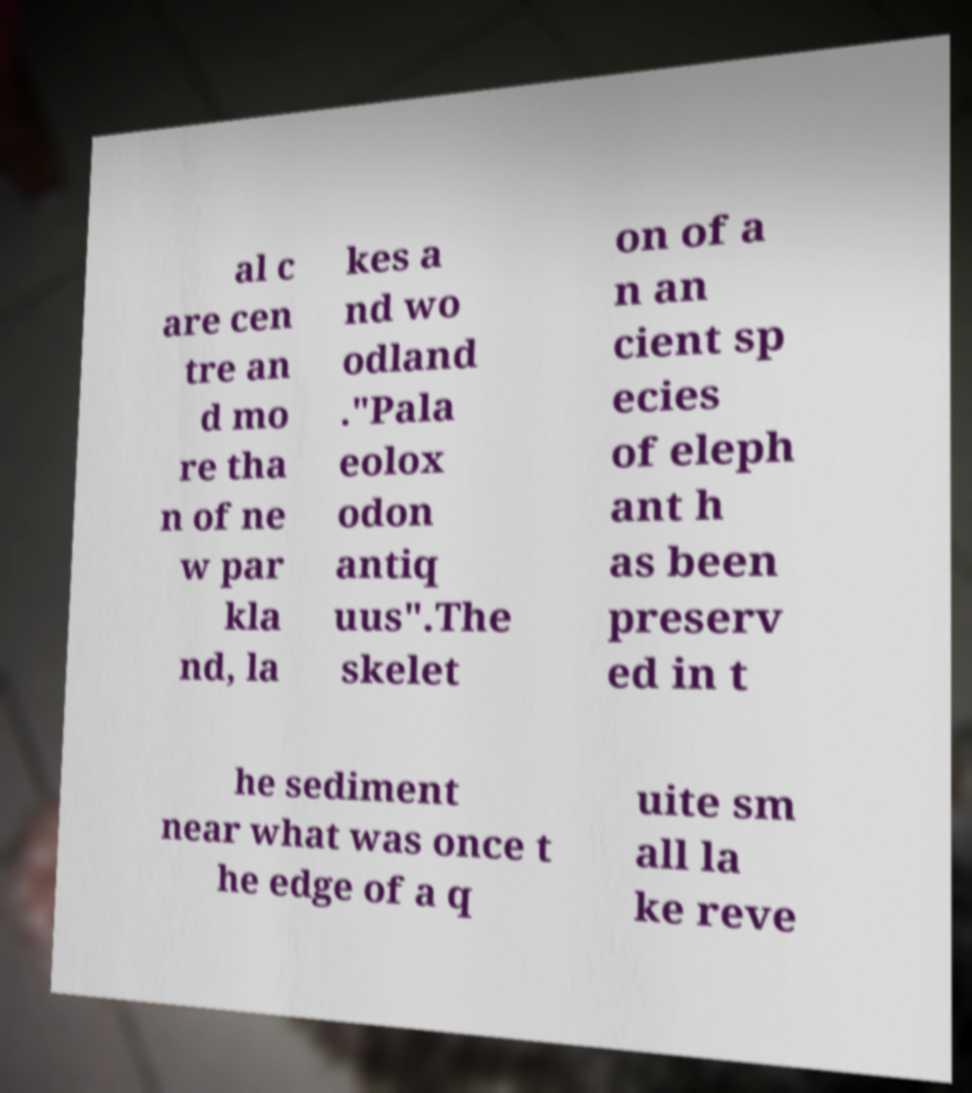Can you accurately transcribe the text from the provided image for me? al c are cen tre an d mo re tha n of ne w par kla nd, la kes a nd wo odland ."Pala eolox odon antiq uus".The skelet on of a n an cient sp ecies of eleph ant h as been preserv ed in t he sediment near what was once t he edge of a q uite sm all la ke reve 